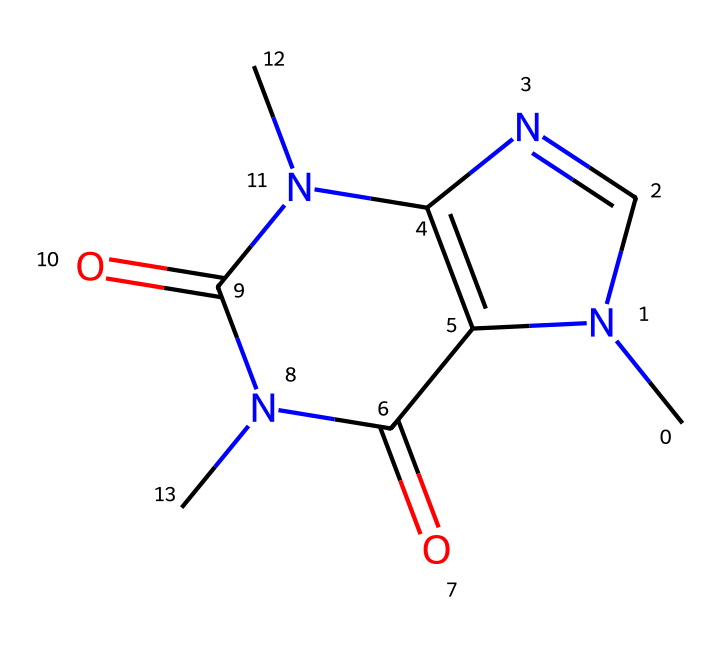What is the molecular formula of caffeine? By inspecting the structure derived from the SMILES representation, we count the atoms of each element present: 8 carbon (C), 10 hydrogen (H), 4 nitrogen (N), and 2 oxygen (O) atoms. Therefore, the molecular formula is derived from these counts as C8H10N4O2.
Answer: C8H10N4O2 How many rings are present in the caffeine structure? Analyzing the chemical structure reveals that it contains two fused rings, which are characteristic of xanthine derivatives. Counting them provides the final number.
Answer: 2 What type of chemical compound is caffeine? Caffeine is categorized as an alkaloid due to the presence of nitrogen atoms in its ring structure, which affects its pharmacological activity and shows characteristics associated with basic nitrogenous compounds.
Answer: alkaloid What functional groups are present in caffeine? The structure shows the presence of amine groups (the nitrogen atoms), and carbonyl groups (the oxygen atoms involved in double bonds), indicating the functional characteristics of caffeine.
Answer: amine and carbonyl How does caffeine affect cognitive behavior? Caffeine primarily acts as a stimulant by blocking adenosine receptors in the brain, leading to increased alertness and reduced perception of fatigue, affecting overall cognitive performance.
Answer: stimulant Which part of caffeine contributes to its stimulating effects? The nitrogen atoms in the structure interact with adenosine receptors, which contributes to the inhibitory effect on downstream signaling pathways, significantly enhancing alertness.
Answer: nitrogen atoms 